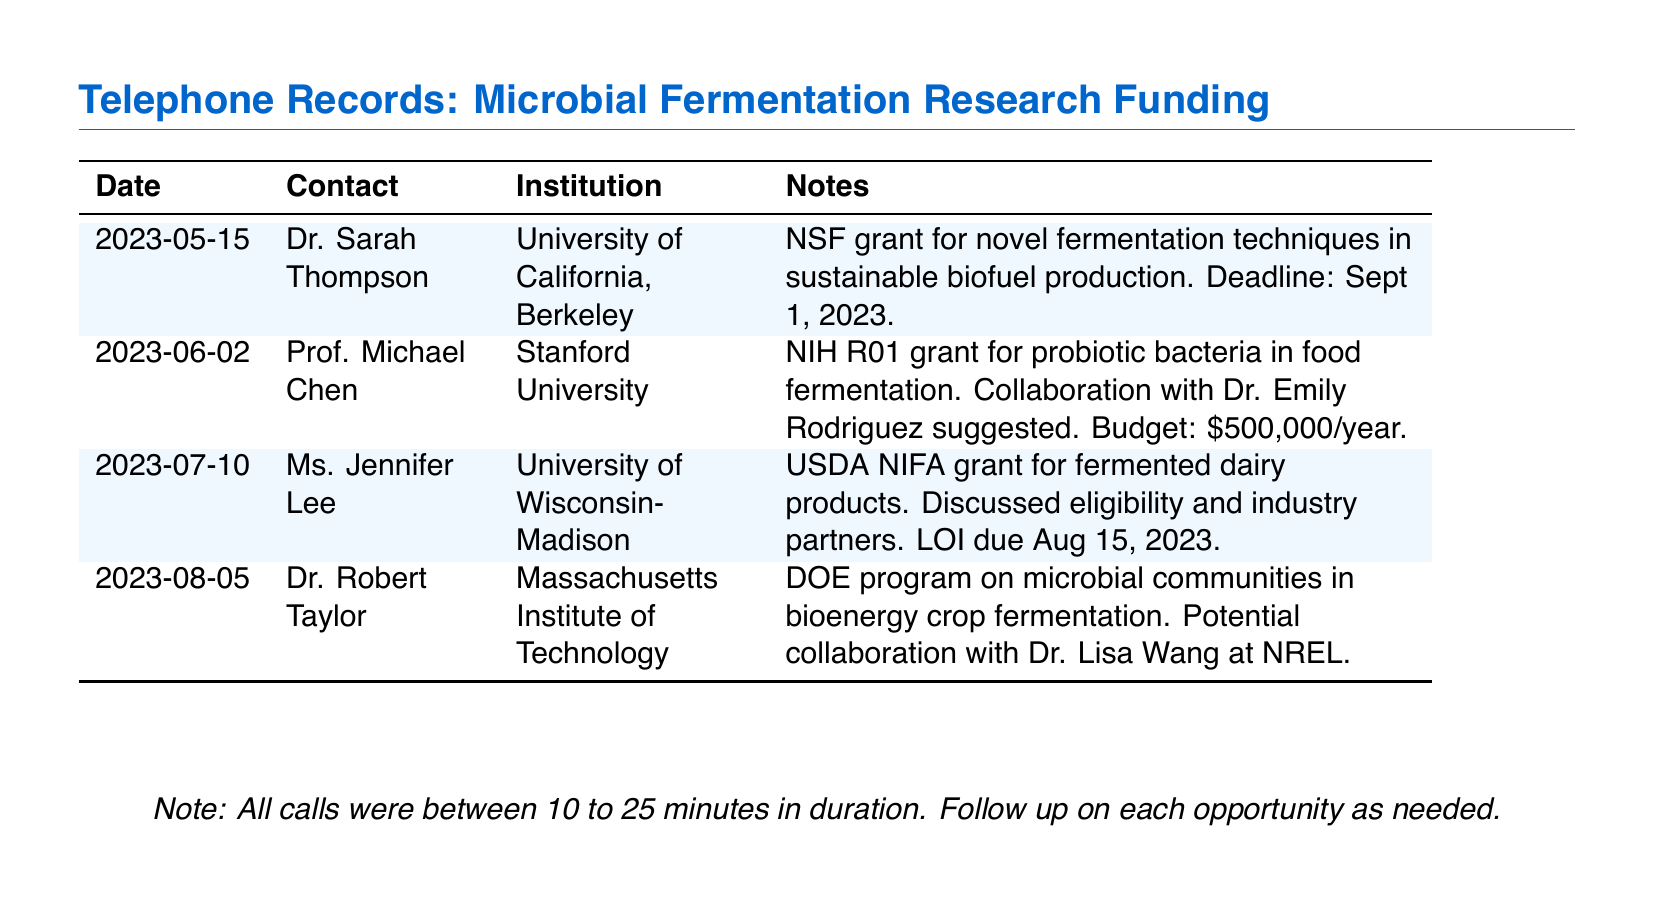What is the deadline for the NSF grant? The document specifies the deadline for the NSF grant as September 1, 2023.
Answer: September 1, 2023 Who was contacted about the USDA NIFA grant? According to the records, Ms. Jennifer Lee was the contact person regarding the USDA NIFA grant.
Answer: Ms. Jennifer Lee What is the budget for the NIH R01 grant? The budget for the NIH R01 grant, as discussed, is $500,000 per year.
Answer: $500,000/year What institution is Dr. Sarah Thompson affiliated with? The document states that Dr. Sarah Thompson is affiliated with the University of California, Berkeley.
Answer: University of California, Berkeley How many potential collaborations were suggested in the calls? The records indicate two suggested collaborations: one with Dr. Emily Rodriguez and another with Dr. Lisa Wang.
Answer: Two What type of grant was discussed with Dr. Robert Taylor? The grant discussed with Dr. Robert Taylor was related to the DOE program on microbial communities in bioenergy crop fermentation.
Answer: DOE program What is the purpose of the USDA NIFA grant? The USDA NIFA grant is focused on fermented dairy products, as noted in the document.
Answer: Fermented dairy products When is the LOI due for the USDA grant? The document informs that the LOI for the USDA grant is due on August 15, 2023.
Answer: August 15, 2023 